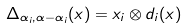<formula> <loc_0><loc_0><loc_500><loc_500>\Delta _ { \alpha _ { i } , \alpha - \alpha _ { i } } ( x ) = x _ { i } \otimes d _ { i } ( x )</formula> 